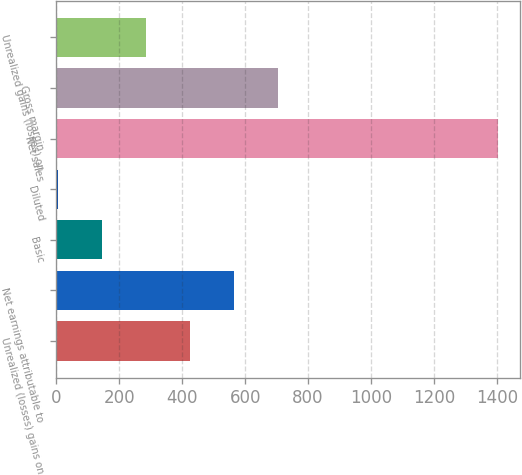Convert chart to OTSL. <chart><loc_0><loc_0><loc_500><loc_500><bar_chart><fcel>Unrealized (losses) gains on<fcel>Net earnings attributable to<fcel>Basic<fcel>Diluted<fcel>Net sales<fcel>Gross margin<fcel>Unrealized gains (losses) on<nl><fcel>425.58<fcel>565.33<fcel>146.09<fcel>6.35<fcel>1403.8<fcel>705.08<fcel>285.84<nl></chart> 